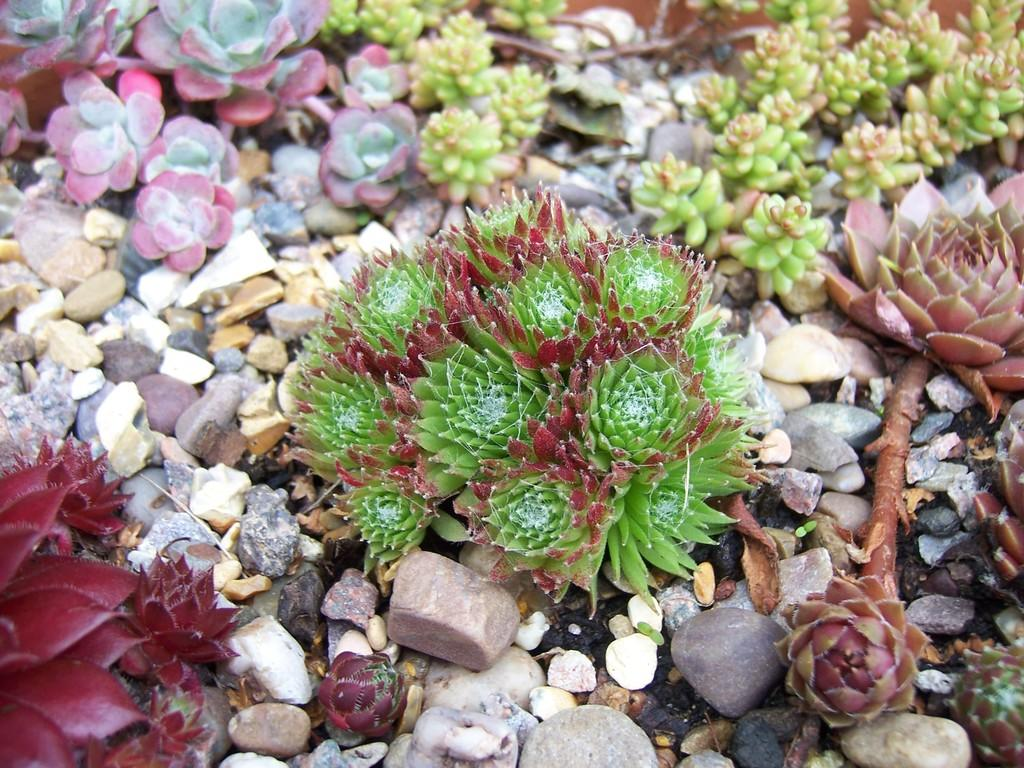What type of plants can be seen in the image? There are flowers in the image. Can you describe the colors of the flowers? The flowers are in different colors. What is located below the flowers in the image? There are small rocks below the flowers. How does the boy sort the flowers in the image? There is no boy present in the image, so the question cannot be answered. 